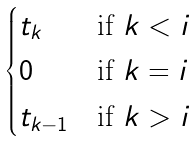<formula> <loc_0><loc_0><loc_500><loc_500>\begin{cases} t _ { k } & \text {if } k < i \\ 0 & \text {if } k = i \\ t _ { k - 1 } & \text {if } k > i \end{cases}</formula> 